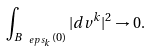Convert formula to latex. <formula><loc_0><loc_0><loc_500><loc_500>\int _ { B _ { \ e p s _ { k } } ( 0 ) } | d v ^ { k } | ^ { 2 } \to 0 .</formula> 